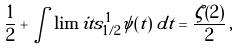<formula> <loc_0><loc_0><loc_500><loc_500>\frac { 1 } { 2 } + \int \lim i t s _ { 1 / 2 } ^ { 1 } \psi ( t ) \, d t = \frac { \zeta ( 2 ) } { 2 } \, ,</formula> 